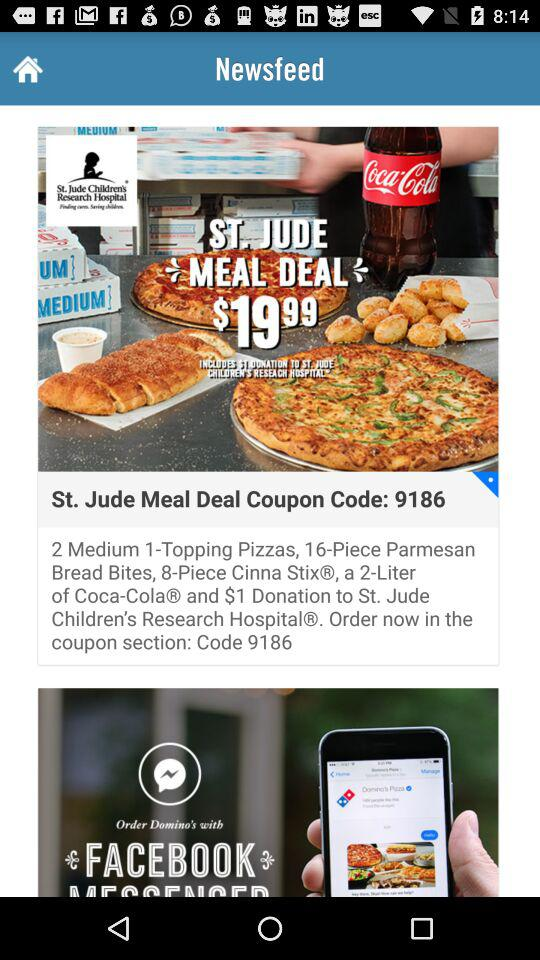What is the price of the "St. Jude Meal Deal"? The price of the "St. Jude Meal Deal" is $19.99. 